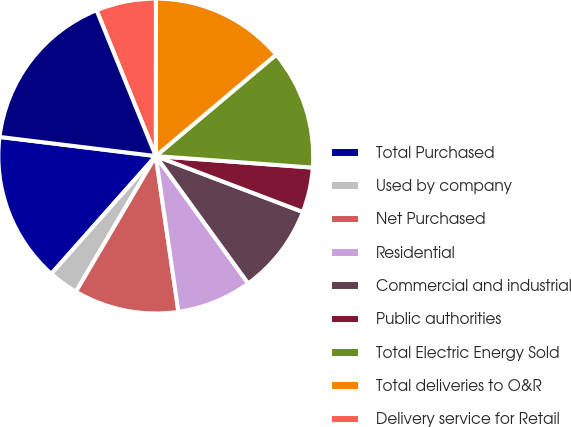Convert chart to OTSL. <chart><loc_0><loc_0><loc_500><loc_500><pie_chart><fcel>Total Purchased<fcel>Used by company<fcel>Net Purchased<fcel>Residential<fcel>Commercial and industrial<fcel>Public authorities<fcel>Total Electric Energy Sold<fcel>Total deliveries to O&R<fcel>Delivery service for Retail<fcel>Total Deliveries In Franchise<nl><fcel>15.39%<fcel>3.08%<fcel>10.77%<fcel>7.69%<fcel>9.23%<fcel>4.61%<fcel>12.31%<fcel>13.85%<fcel>6.15%<fcel>16.92%<nl></chart> 